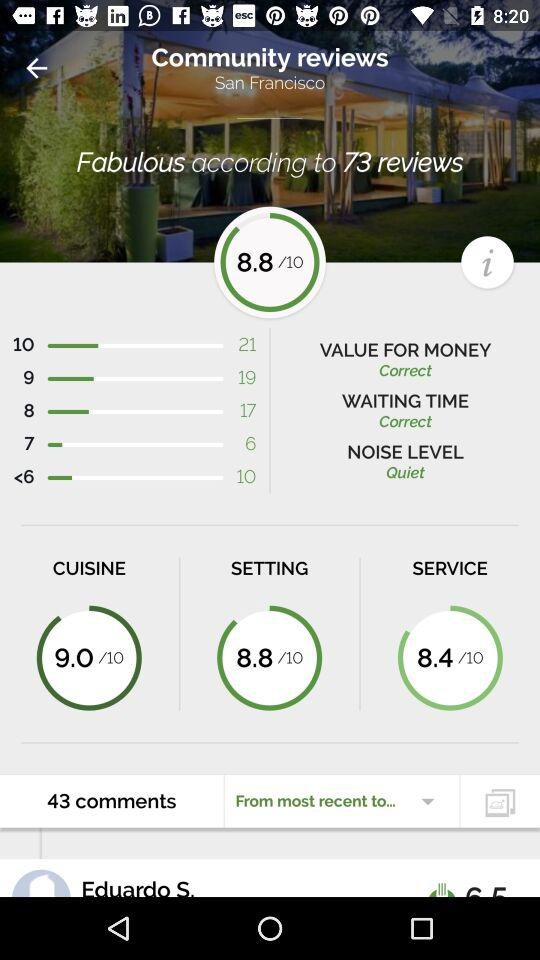What's the noise level? The noise level is "Quiet". 